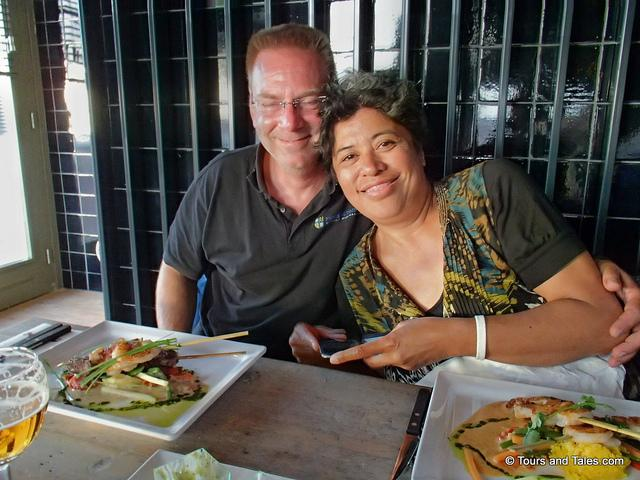What will this couple use to dine here? Please explain your reasoning. chopsticks. These utensils are sitting on both plates. 